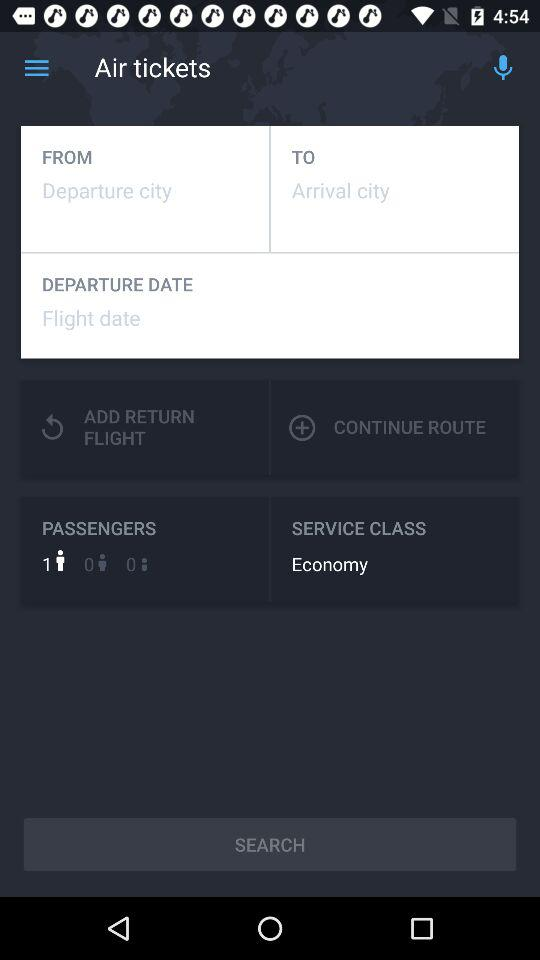How many passengers are there? There is 1 passenger. 